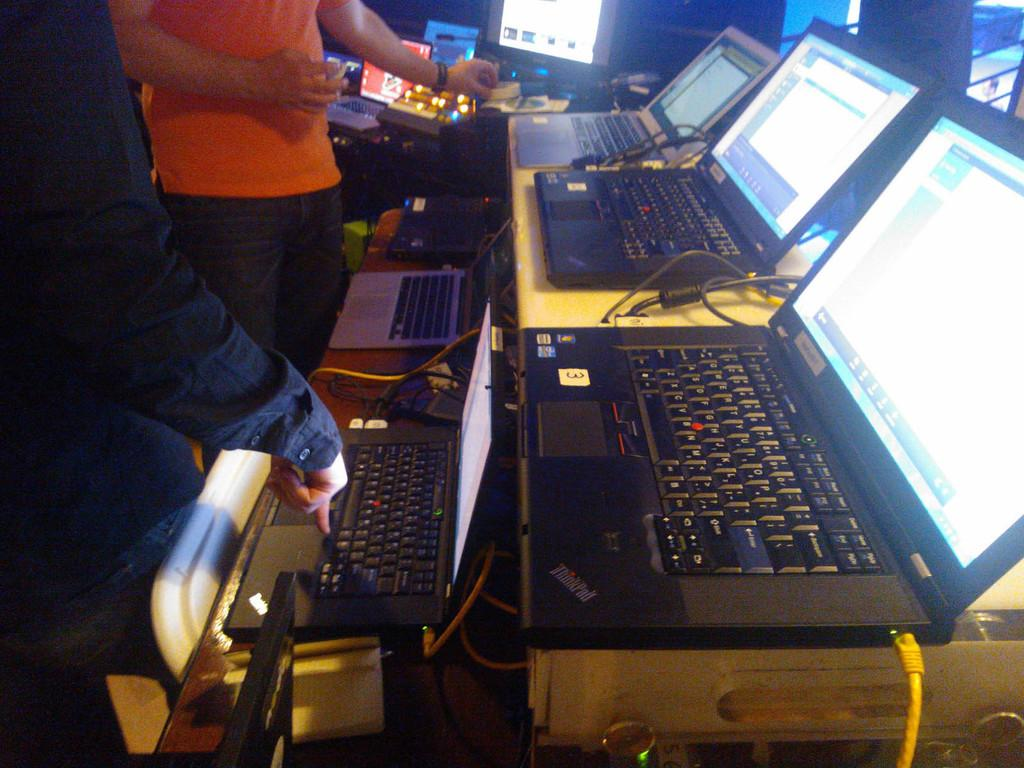<image>
Create a compact narrative representing the image presented. the number 3 is on the front of the laptop 